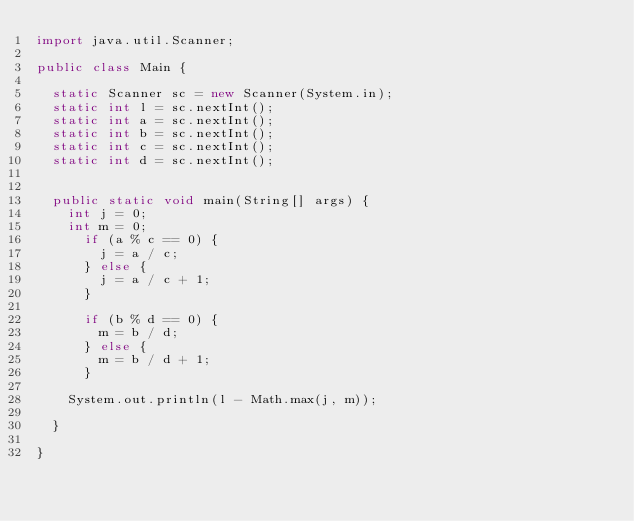<code> <loc_0><loc_0><loc_500><loc_500><_Java_>import java.util.Scanner;

public class Main {

	static Scanner sc = new Scanner(System.in);
	static int l = sc.nextInt();
	static int a = sc.nextInt();
	static int b = sc.nextInt();
	static int c = sc.nextInt();
	static int d = sc.nextInt();


	public static void main(String[] args) {
		int j = 0;
		int m = 0;
			if (a % c == 0) {
				j = a / c;
			} else {
				j = a / c + 1;
			}

			if (b % d == 0) {
				m = b / d;
			} else {
				m = b / d + 1;
			}

		System.out.println(l - Math.max(j, m));

	}

}
</code> 